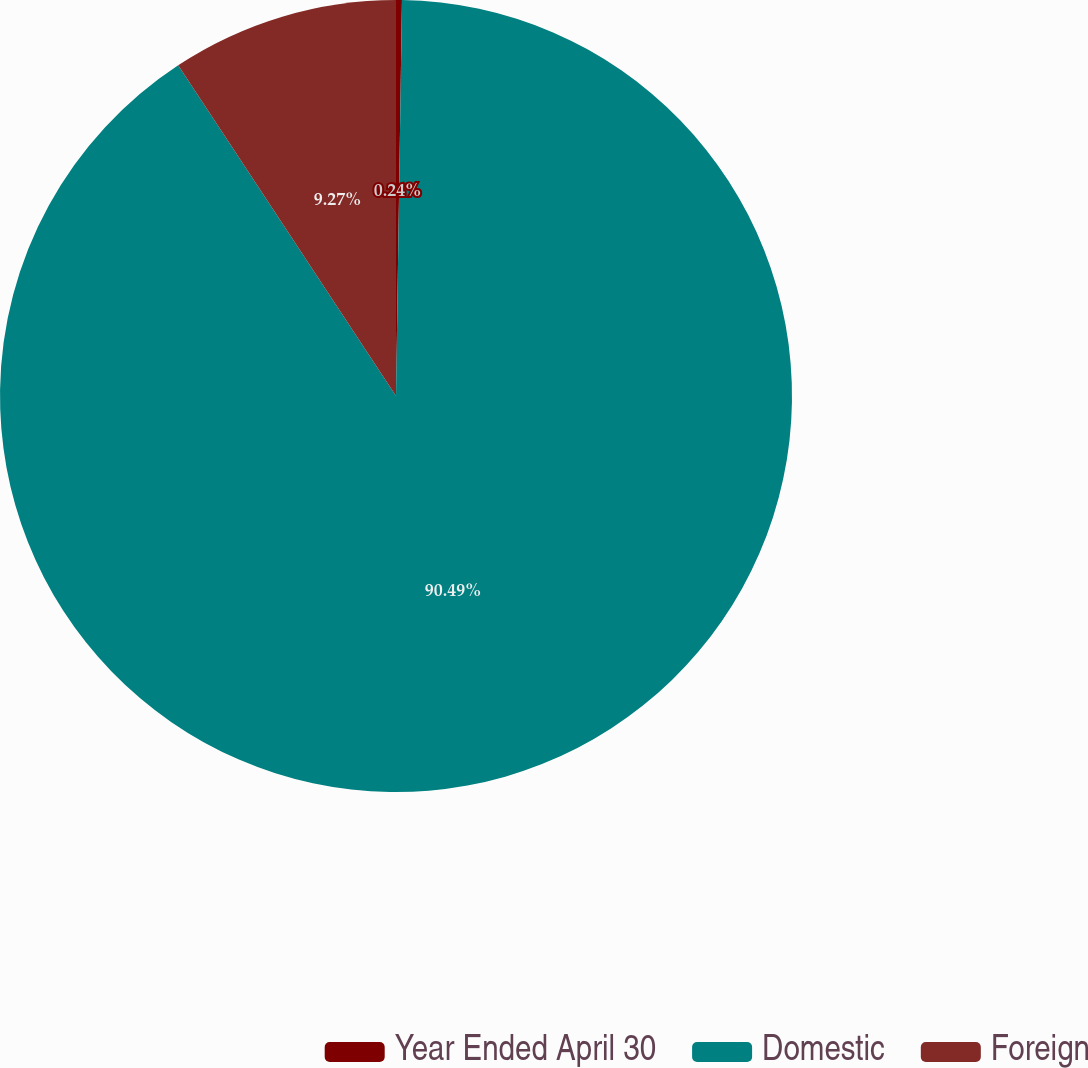<chart> <loc_0><loc_0><loc_500><loc_500><pie_chart><fcel>Year Ended April 30<fcel>Domestic<fcel>Foreign<nl><fcel>0.24%<fcel>90.49%<fcel>9.27%<nl></chart> 